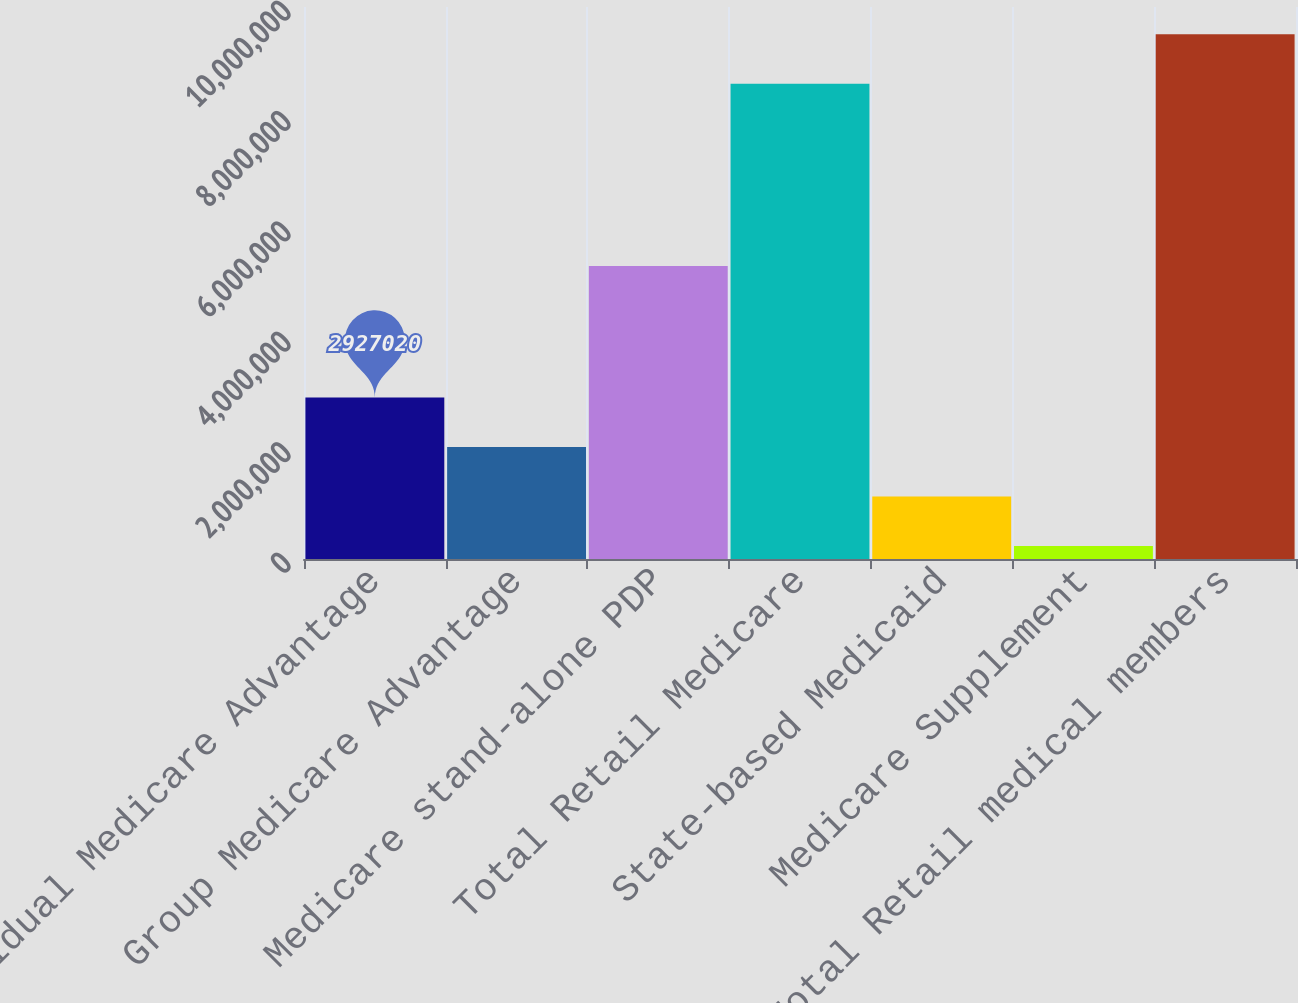Convert chart to OTSL. <chart><loc_0><loc_0><loc_500><loc_500><bar_chart><fcel>Individual Medicare Advantage<fcel>Group Medicare Advantage<fcel>Medicare stand-alone PDP<fcel>Total Retail Medicare<fcel>State-based Medicaid<fcel>Medicare Supplement<fcel>Total Retail medical members<nl><fcel>2.92702e+06<fcel>2.02998e+06<fcel>5.3081e+06<fcel>8.6103e+06<fcel>1.13294e+06<fcel>235900<fcel>9.50734e+06<nl></chart> 